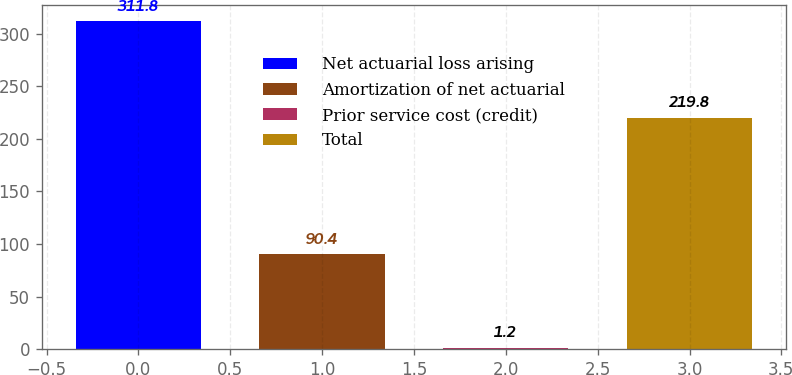<chart> <loc_0><loc_0><loc_500><loc_500><bar_chart><fcel>Net actuarial loss arising<fcel>Amortization of net actuarial<fcel>Prior service cost (credit)<fcel>Total<nl><fcel>311.8<fcel>90.4<fcel>1.2<fcel>219.8<nl></chart> 